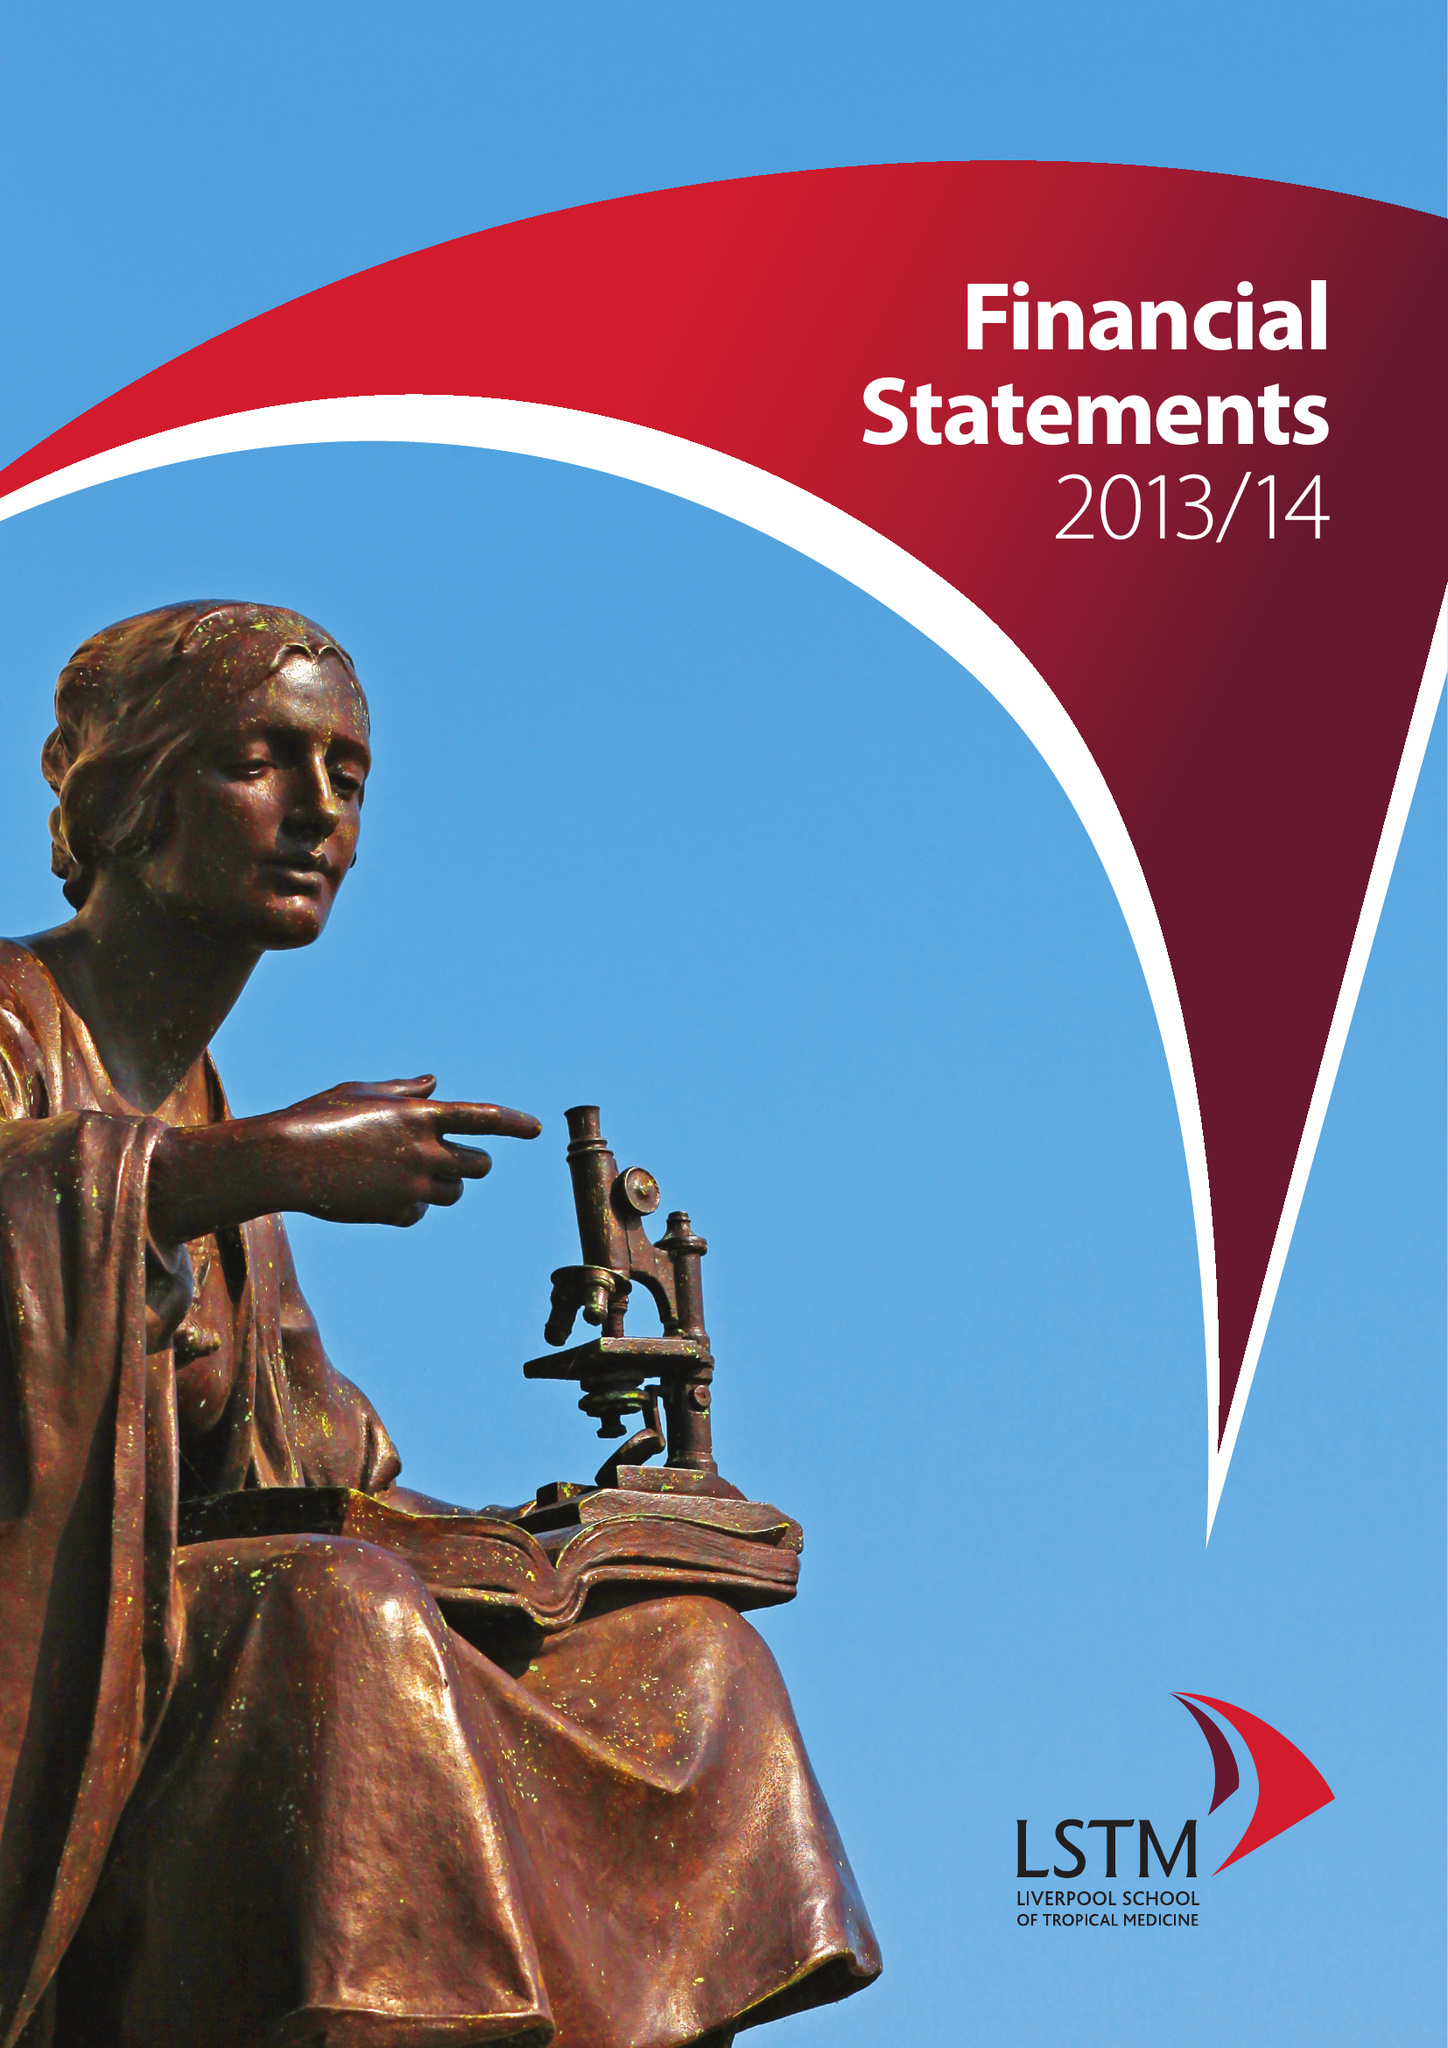What is the value for the report_date?
Answer the question using a single word or phrase. 2014-07-31 